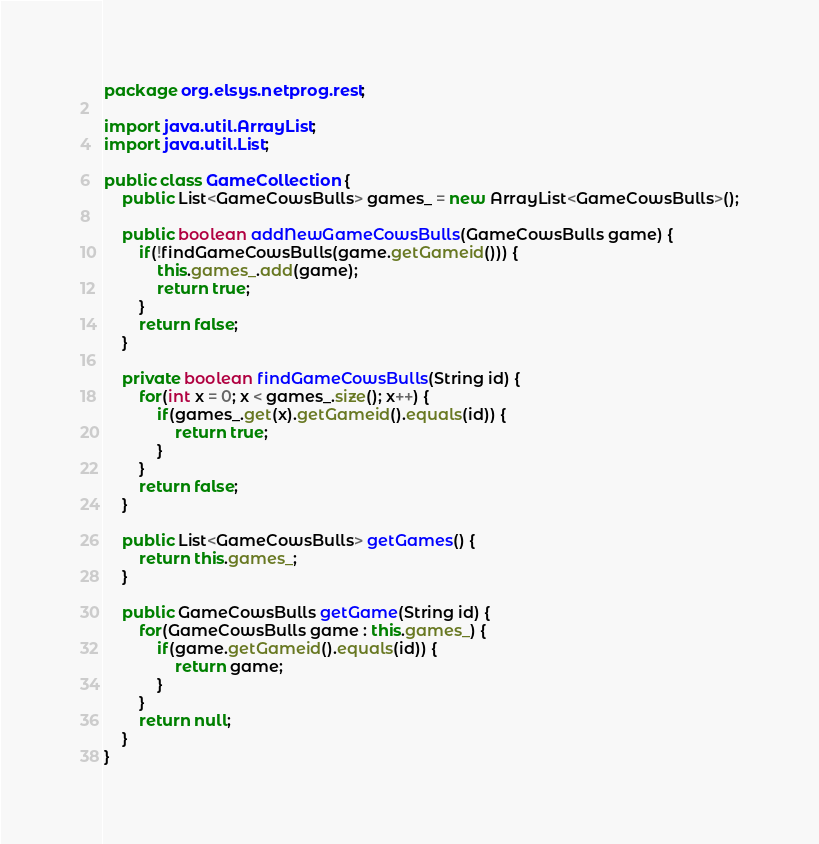Convert code to text. <code><loc_0><loc_0><loc_500><loc_500><_Java_>package org.elsys.netprog.rest;

import java.util.ArrayList;
import java.util.List;

public class GameCollection {
	public List<GameCowsBulls> games_ = new ArrayList<GameCowsBulls>();
	
	public boolean addNewGameCowsBulls(GameCowsBulls game) {
		if(!findGameCowsBulls(game.getGameid())) {
			this.games_.add(game);
			return true;
		}
		return false;
	}

	private boolean findGameCowsBulls(String id) {
		for(int x = 0; x < games_.size(); x++) {
			if(games_.get(x).getGameid().equals(id)) {
				return true;
			}
		}
		return false;
	}

	public List<GameCowsBulls> getGames() {
		return this.games_;
	}
	
	public GameCowsBulls getGame(String id) {
		for(GameCowsBulls game : this.games_) {
			if(game.getGameid().equals(id)) {
				return game;
			}
		}
		return null;
	}
}
</code> 